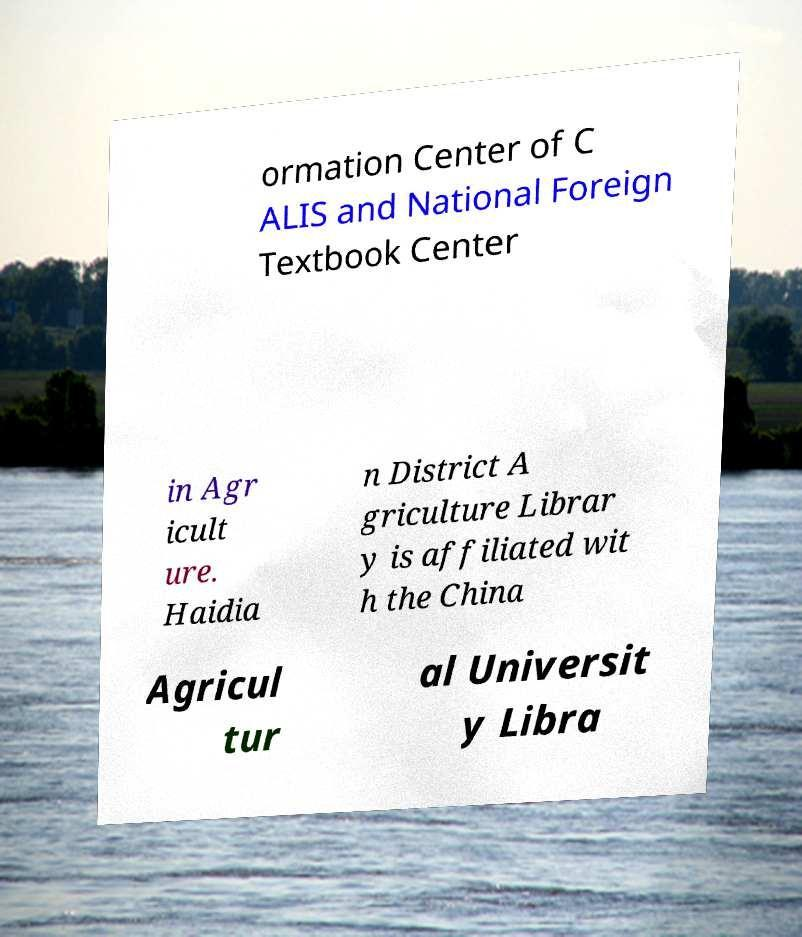Please read and relay the text visible in this image. What does it say? ormation Center of C ALIS and National Foreign Textbook Center in Agr icult ure. Haidia n District A griculture Librar y is affiliated wit h the China Agricul tur al Universit y Libra 